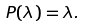<formula> <loc_0><loc_0><loc_500><loc_500>P ( \lambda ) = \lambda .</formula> 